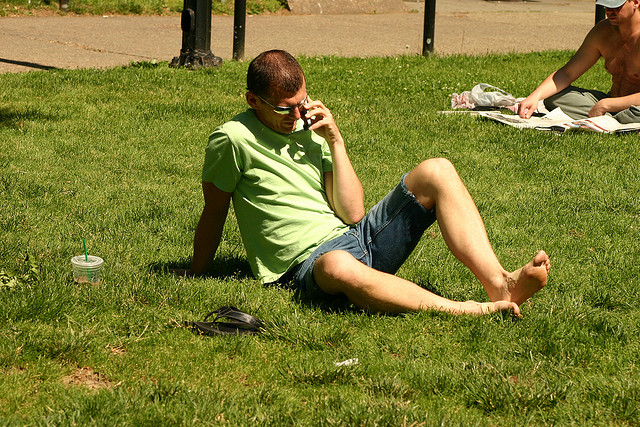<image>What kind of shoes does she have on? It is unanswerable what kind of shoes she has on. It can be seen none or flip flops. What kind of shoes does she have on? I am not sure what kind of shoes she has on. The image does not show any shoes. 